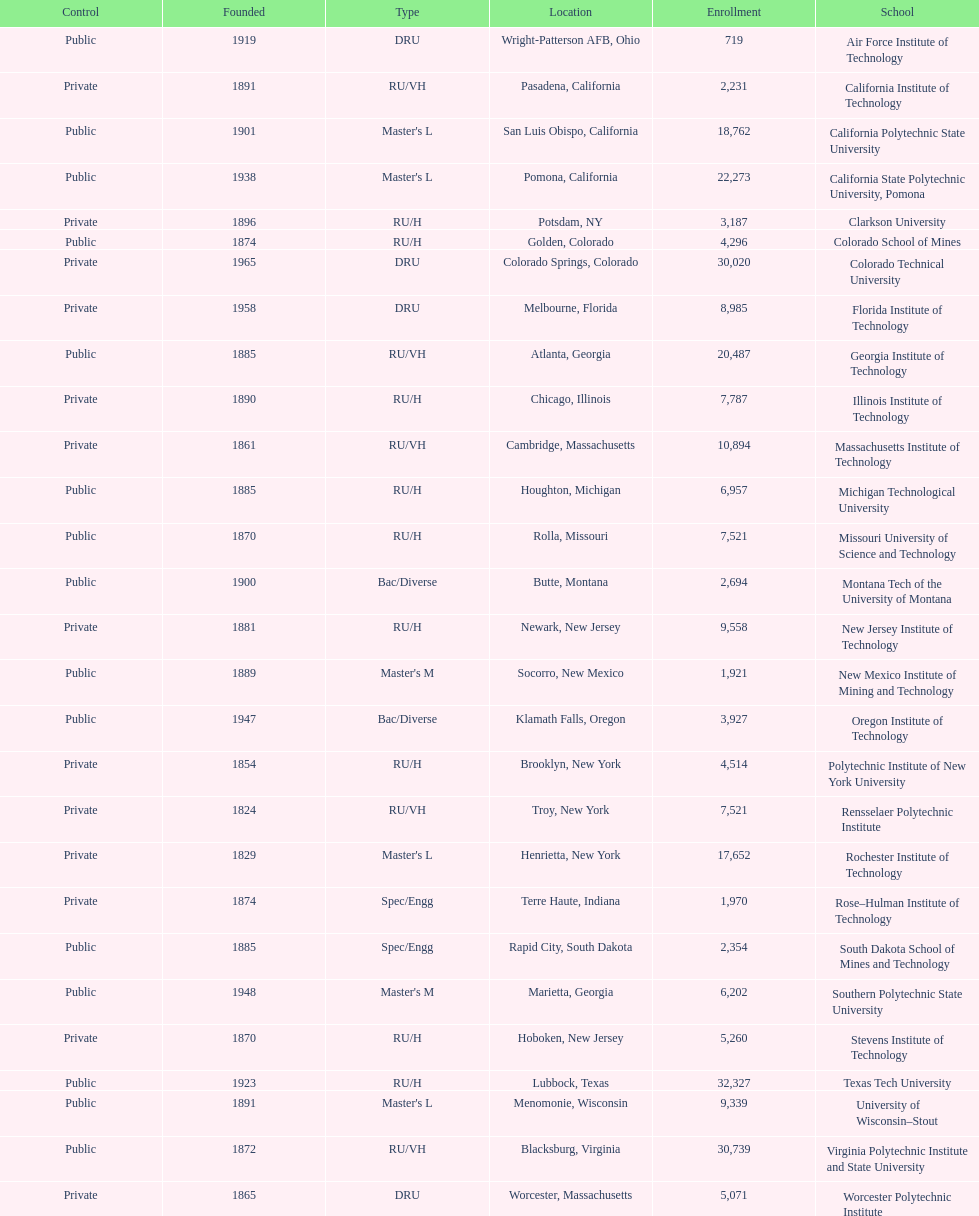How many of the universities were located in california? 3. 